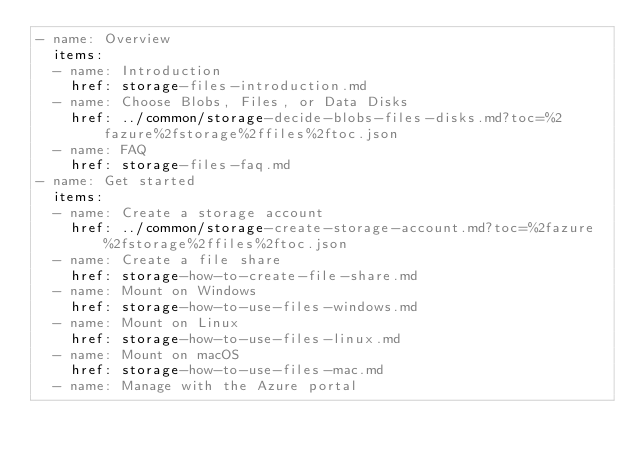<code> <loc_0><loc_0><loc_500><loc_500><_YAML_>- name: Overview
  items:
  - name: Introduction
    href: storage-files-introduction.md
  - name: Choose Blobs, Files, or Data Disks
    href: ../common/storage-decide-blobs-files-disks.md?toc=%2fazure%2fstorage%2ffiles%2ftoc.json
  - name: FAQ
    href: storage-files-faq.md
- name: Get started
  items:
  - name: Create a storage account
    href: ../common/storage-create-storage-account.md?toc=%2fazure%2fstorage%2ffiles%2ftoc.json
  - name: Create a file share
    href: storage-how-to-create-file-share.md
  - name: Mount on Windows
    href: storage-how-to-use-files-windows.md
  - name: Mount on Linux
    href: storage-how-to-use-files-linux.md
  - name: Mount on macOS
    href: storage-how-to-use-files-mac.md
  - name: Manage with the Azure portal</code> 